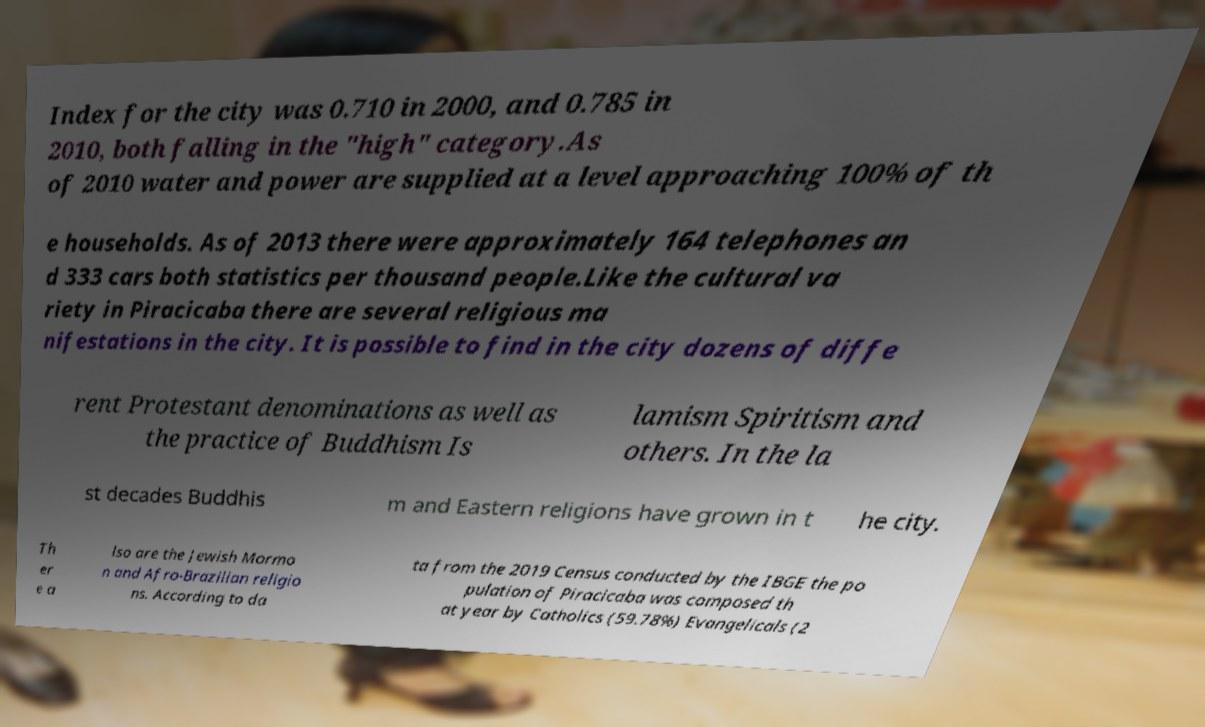Could you extract and type out the text from this image? Index for the city was 0.710 in 2000, and 0.785 in 2010, both falling in the "high" category.As of 2010 water and power are supplied at a level approaching 100% of th e households. As of 2013 there were approximately 164 telephones an d 333 cars both statistics per thousand people.Like the cultural va riety in Piracicaba there are several religious ma nifestations in the city. It is possible to find in the city dozens of diffe rent Protestant denominations as well as the practice of Buddhism Is lamism Spiritism and others. In the la st decades Buddhis m and Eastern religions have grown in t he city. Th er e a lso are the Jewish Mormo n and Afro-Brazilian religio ns. According to da ta from the 2019 Census conducted by the IBGE the po pulation of Piracicaba was composed th at year by Catholics (59.78%) Evangelicals (2 